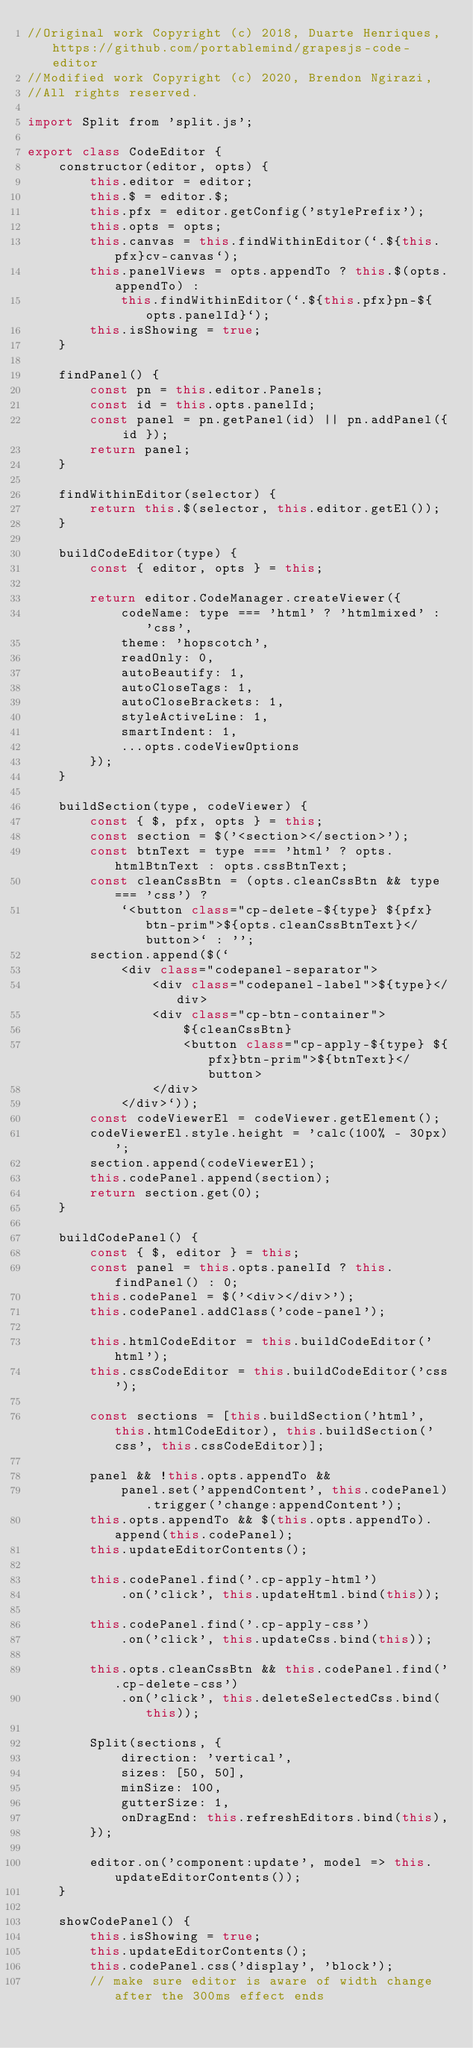Convert code to text. <code><loc_0><loc_0><loc_500><loc_500><_JavaScript_>//Original work Copyright (c) 2018, Duarte Henriques, https://github.com/portablemind/grapesjs-code-editor
//Modified work Copyright (c) 2020, Brendon Ngirazi,
//All rights reserved.

import Split from 'split.js';

export class CodeEditor {
    constructor(editor, opts) {
        this.editor = editor;
        this.$ = editor.$;
        this.pfx = editor.getConfig('stylePrefix');
        this.opts = opts;
        this.canvas = this.findWithinEditor(`.${this.pfx}cv-canvas`);
        this.panelViews = opts.appendTo ? this.$(opts.appendTo) :
            this.findWithinEditor(`.${this.pfx}pn-${opts.panelId}`);
        this.isShowing = true;
    }

    findPanel() {
        const pn = this.editor.Panels;
        const id = this.opts.panelId;
        const panel = pn.getPanel(id) || pn.addPanel({ id });
        return panel;
    }

    findWithinEditor(selector) {
        return this.$(selector, this.editor.getEl());
    }

    buildCodeEditor(type) {
        const { editor, opts } = this;

        return editor.CodeManager.createViewer({
            codeName: type === 'html' ? 'htmlmixed' : 'css',
            theme: 'hopscotch',
            readOnly: 0,
            autoBeautify: 1,
            autoCloseTags: 1,
            autoCloseBrackets: 1,
            styleActiveLine: 1,
            smartIndent: 1,
            ...opts.codeViewOptions
        });
    }

    buildSection(type, codeViewer) {
        const { $, pfx, opts } = this;
        const section = $('<section></section>');
        const btnText = type === 'html' ? opts.htmlBtnText : opts.cssBtnText;
        const cleanCssBtn = (opts.cleanCssBtn && type === 'css') ?
            `<button class="cp-delete-${type} ${pfx}btn-prim">${opts.cleanCssBtnText}</button>` : '';
        section.append($(`
            <div class="codepanel-separator">
                <div class="codepanel-label">${type}</div>
                <div class="cp-btn-container">
                    ${cleanCssBtn}
                    <button class="cp-apply-${type} ${pfx}btn-prim">${btnText}</button>
                </div>
            </div>`));
        const codeViewerEl = codeViewer.getElement();
        codeViewerEl.style.height = 'calc(100% - 30px)';
        section.append(codeViewerEl);
        this.codePanel.append(section);
        return section.get(0);
    }

    buildCodePanel() {
        const { $, editor } = this;
        const panel = this.opts.panelId ? this.findPanel() : 0;
        this.codePanel = $('<div></div>');
        this.codePanel.addClass('code-panel');

        this.htmlCodeEditor = this.buildCodeEditor('html');
        this.cssCodeEditor = this.buildCodeEditor('css');

        const sections = [this.buildSection('html', this.htmlCodeEditor), this.buildSection('css', this.cssCodeEditor)];

        panel && !this.opts.appendTo &&
            panel.set('appendContent', this.codePanel).trigger('change:appendContent');
        this.opts.appendTo && $(this.opts.appendTo).append(this.codePanel);
        this.updateEditorContents();

        this.codePanel.find('.cp-apply-html')
            .on('click', this.updateHtml.bind(this));

        this.codePanel.find('.cp-apply-css')
            .on('click', this.updateCss.bind(this));

        this.opts.cleanCssBtn && this.codePanel.find('.cp-delete-css')
            .on('click', this.deleteSelectedCss.bind(this));

        Split(sections, {
            direction: 'vertical',
            sizes: [50, 50],
            minSize: 100,
            gutterSize: 1,
            onDragEnd: this.refreshEditors.bind(this),
        });

        editor.on('component:update', model => this.updateEditorContents());
    }

    showCodePanel() {
        this.isShowing = true;
        this.updateEditorContents();
        this.codePanel.css('display', 'block');
        // make sure editor is aware of width change after the 300ms effect ends</code> 